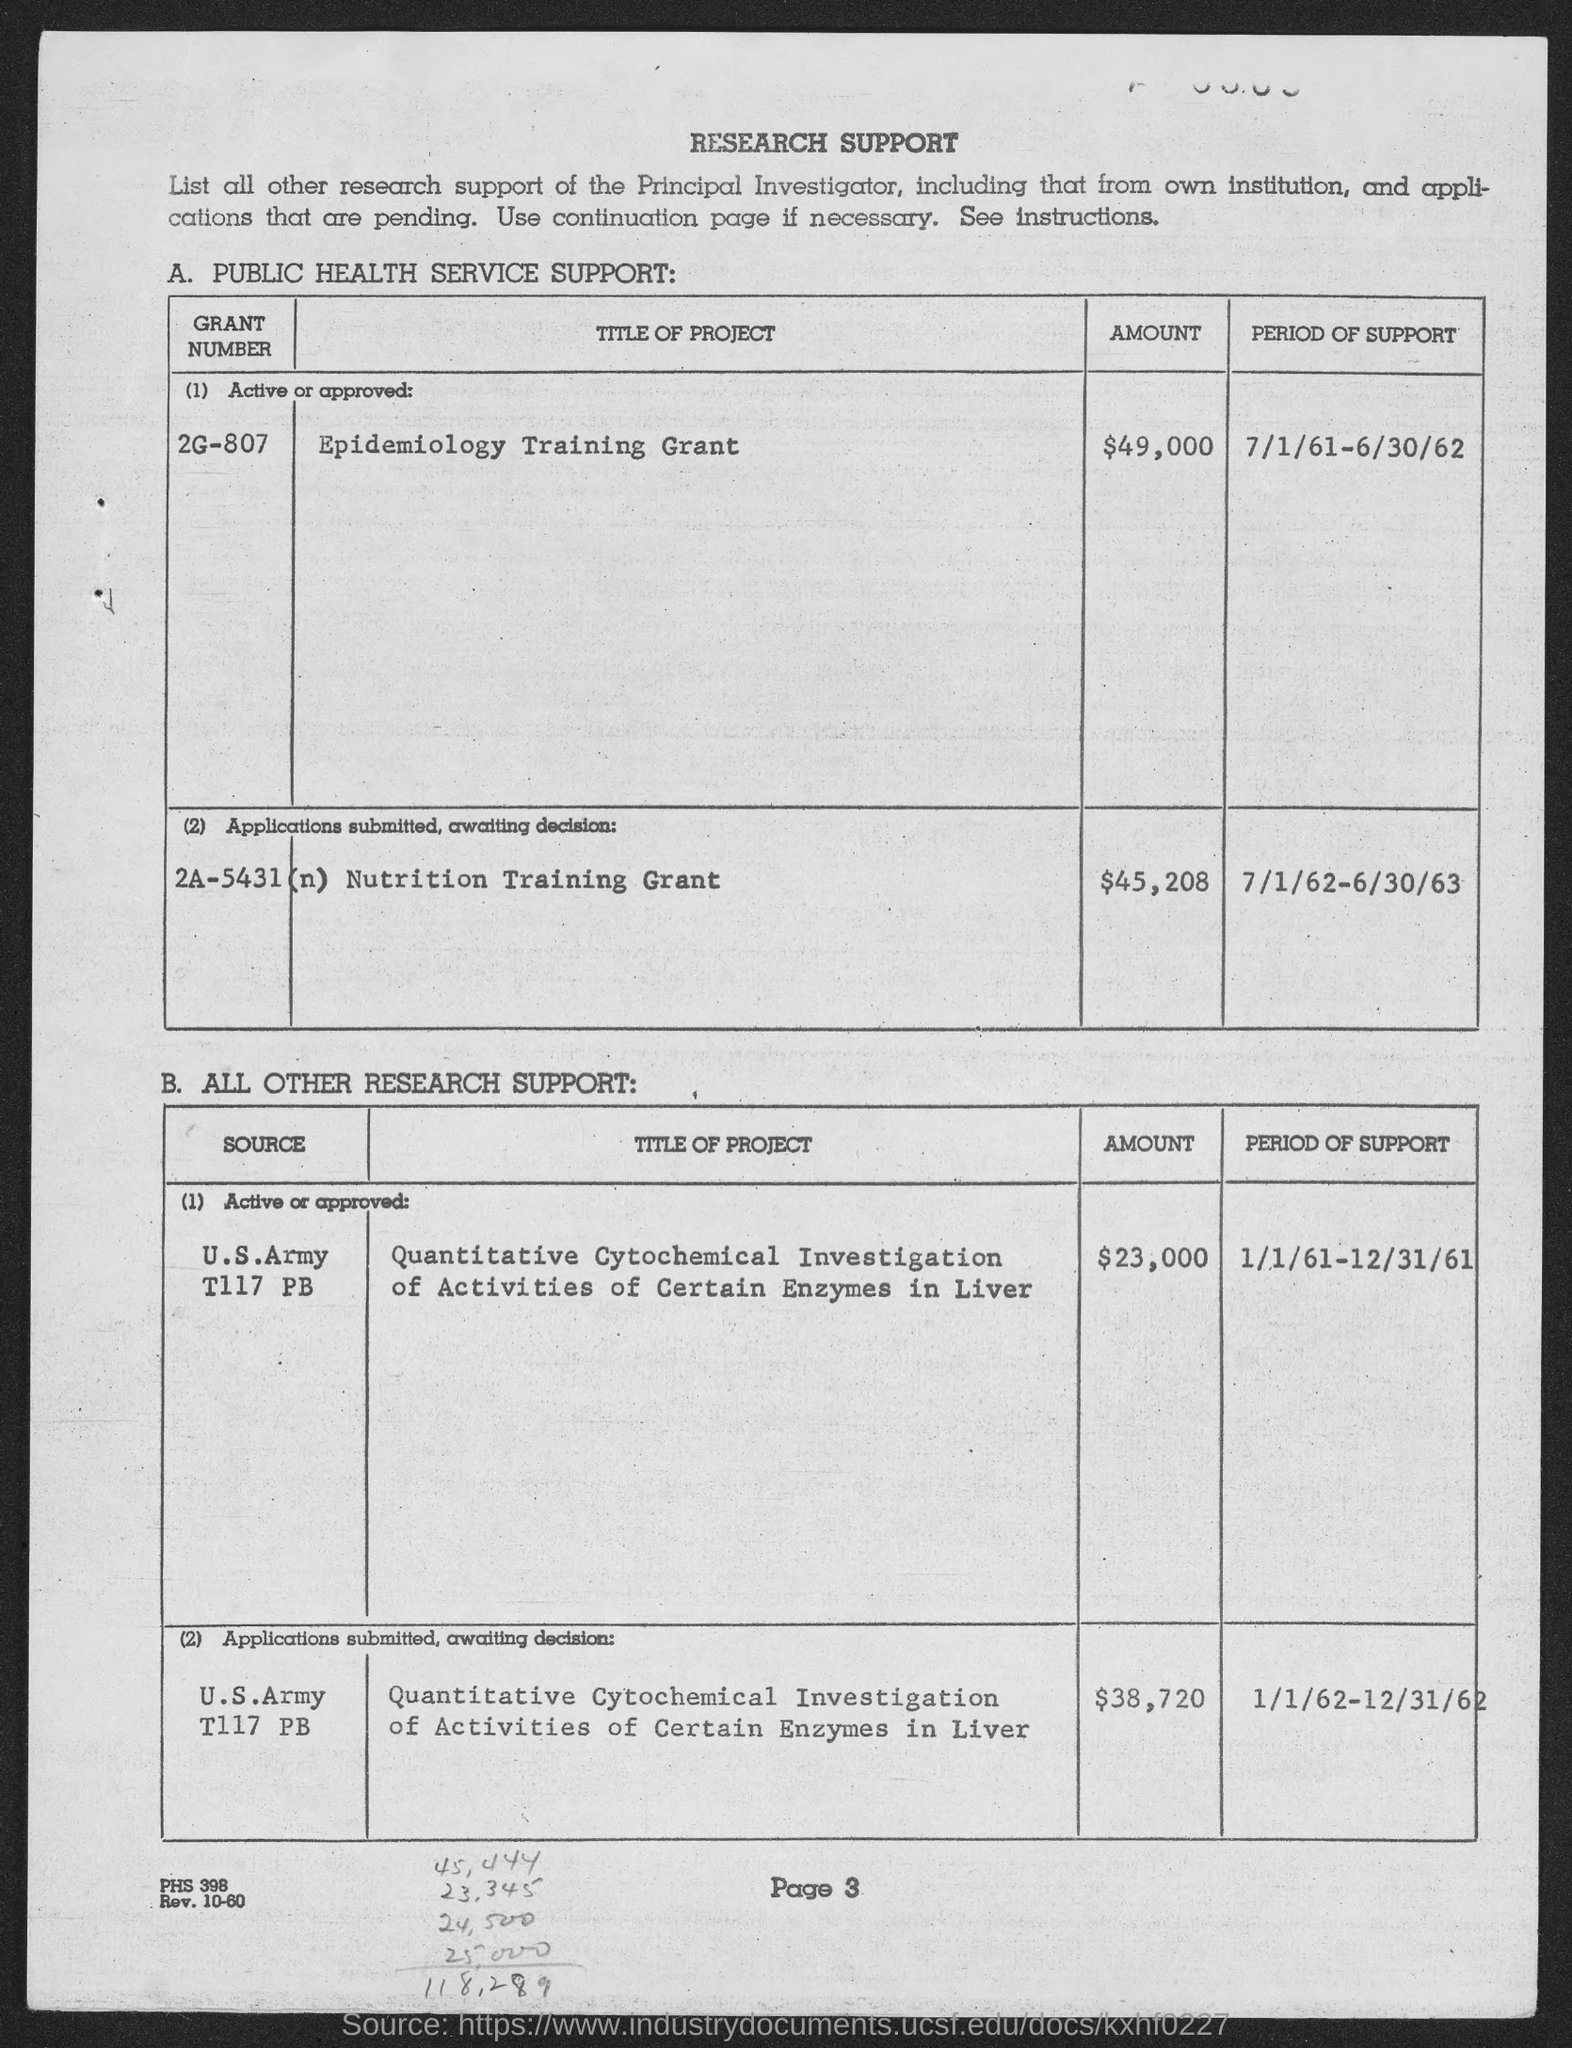What is the grant number for the project titled 'Epidemiology Training Grant'?
Provide a short and direct response. 2G-807. What is the  amount of grant mentioned for the grant no. 2G-807?
Give a very brief answer. $49,000. What is the period of support for the grant no. 2G-807?
Provide a short and direct response. 7/1/61-6/30/62. What is the title of the project with grant no. 2A-5431 (n)?
Your answer should be very brief. Nutrition training grant. What is the amount of grant mentioned for the grant no. 2A-5431 (n)?
Your response must be concise. $45,208. What is the period of support for the grant no. 2A-5431 (n)?
Ensure brevity in your answer.  7/1/62-6/30/63. What is the page no mentioned in this document?
Keep it short and to the point. Page 3. What is the main title of this document?
Provide a succinct answer. RESEARCH SUPPORT. 